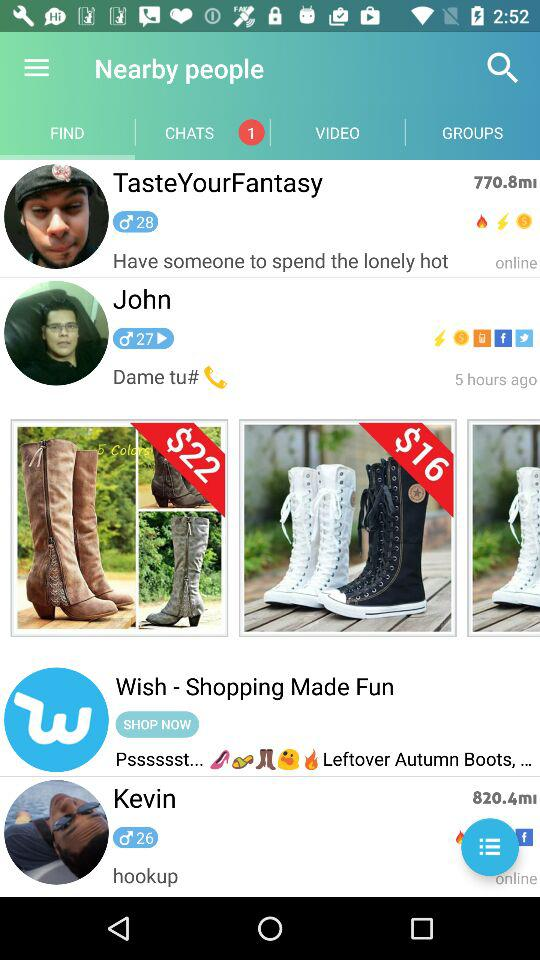How old is Kevin? Kevin is 26 years old. 